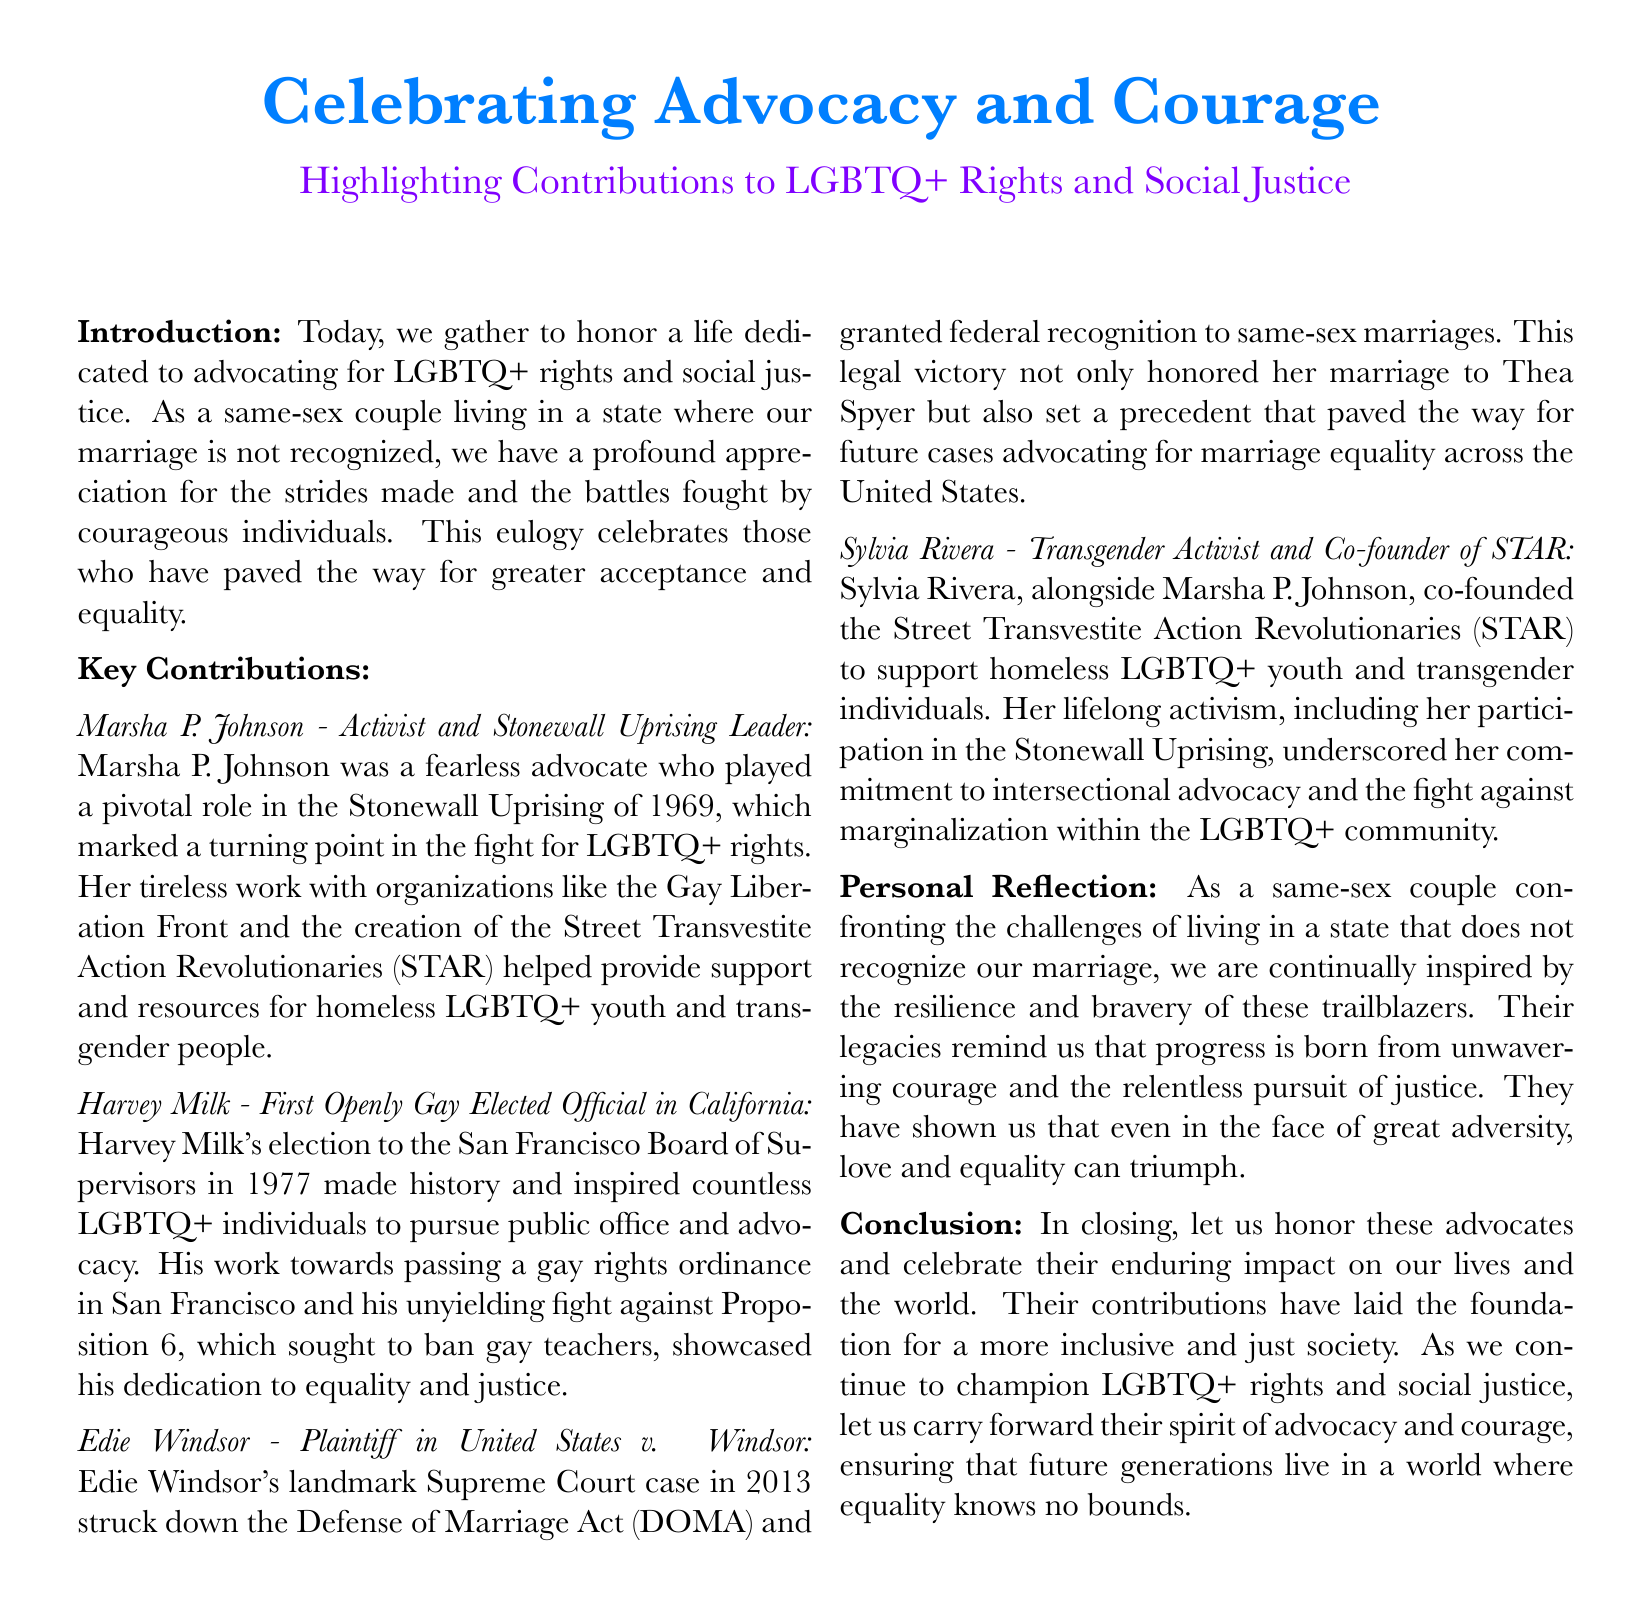What significant event did Marsha P. Johnson contribute to? The Stonewall Uprising of 1969 marked a turning point in the fight for LGBTQ+ rights.
Answer: Stonewall Uprising Who was the first openly gay elected official in California? Harvey Milk's election to the San Francisco Board of Supervisors made history in 1977.
Answer: Harvey Milk What landmark Supreme Court case did Edie Windsor participate in? The case that struck down the Defense of Marriage Act (DOMA) in 2013.
Answer: United States v. Windsor What organization did Sylvia Rivera co-found? Alongside Marsha P. Johnson, she co-founded the Street Transvestite Action Revolutionaries.
Answer: STAR What year did Harvey Milk's historic election occur? His election to the San Francisco Board of Supervisors took place in 1977.
Answer: 1977 What does the eulogy emphasize about the contributions of LGBTQ+ advocates? The eulogy highlights their enduring impact on LGBTQ+ rights and social justice.
Answer: Enduring impact What themes does the personal reflection section of the eulogy address? The personal reflection speaks to resilience and bravery in the face of adversity.
Answer: Resilience and bravery What is the main purpose of this document? The document serves to honor and celebrate the contributions of LGBTQ+ advocates.
Answer: Honor and celebrate 